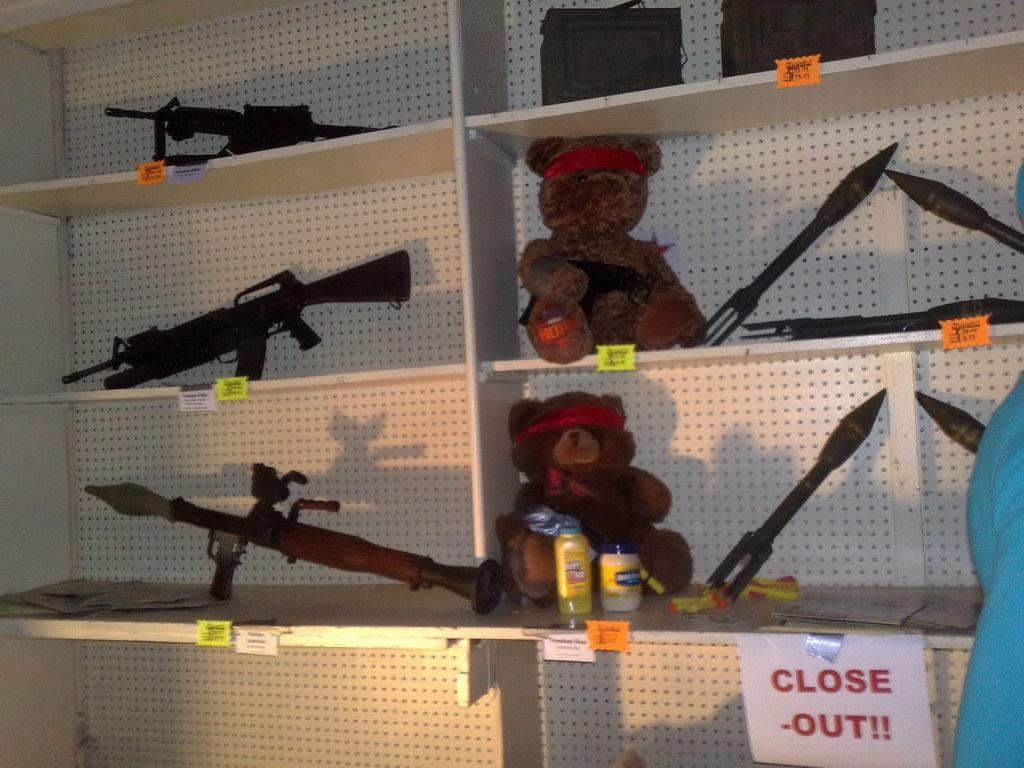What is the main object in the image? There is a rack in the image. What items can be found on the rack? The rack contains teddy bears, bottles, guns, and missiles. Are there any other objects visible in the image? Yes, there are bags at the top of the image. What type of underwear is hanging on the rack in the image? There is no underwear present in the image; the rack contains teddy bears, bottles, guns, and missiles. How much sugar is stored in the bags at the top of the image? There is no sugar mentioned in the image; the bags contain unspecified items. 